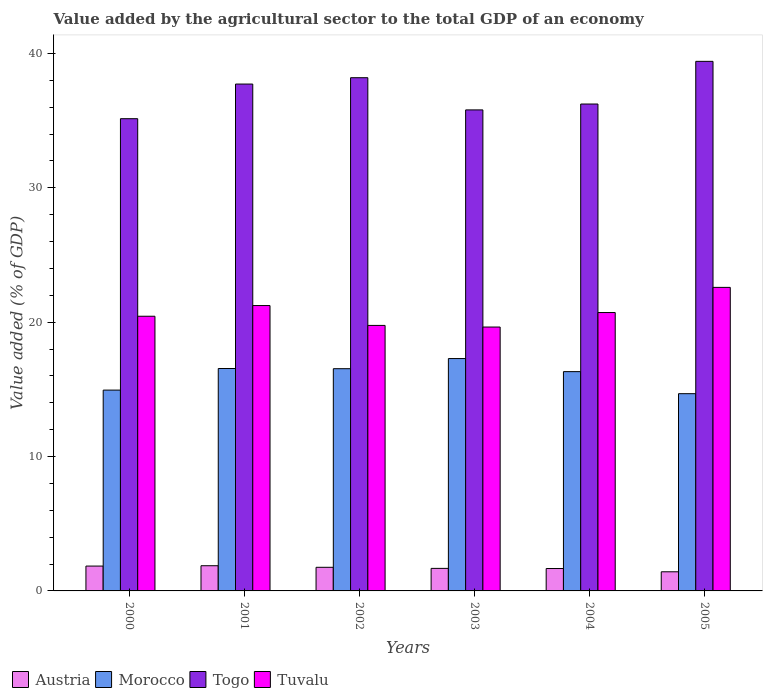How many bars are there on the 2nd tick from the left?
Offer a very short reply. 4. How many bars are there on the 5th tick from the right?
Give a very brief answer. 4. What is the label of the 1st group of bars from the left?
Provide a short and direct response. 2000. What is the value added by the agricultural sector to the total GDP in Togo in 2003?
Your response must be concise. 35.8. Across all years, what is the maximum value added by the agricultural sector to the total GDP in Morocco?
Your response must be concise. 17.29. Across all years, what is the minimum value added by the agricultural sector to the total GDP in Morocco?
Offer a very short reply. 14.68. In which year was the value added by the agricultural sector to the total GDP in Tuvalu maximum?
Keep it short and to the point. 2005. What is the total value added by the agricultural sector to the total GDP in Togo in the graph?
Your answer should be compact. 222.49. What is the difference between the value added by the agricultural sector to the total GDP in Austria in 2002 and that in 2005?
Your response must be concise. 0.33. What is the difference between the value added by the agricultural sector to the total GDP in Togo in 2000 and the value added by the agricultural sector to the total GDP in Austria in 2004?
Provide a succinct answer. 33.47. What is the average value added by the agricultural sector to the total GDP in Tuvalu per year?
Your answer should be compact. 20.73. In the year 2004, what is the difference between the value added by the agricultural sector to the total GDP in Tuvalu and value added by the agricultural sector to the total GDP in Morocco?
Give a very brief answer. 4.4. In how many years, is the value added by the agricultural sector to the total GDP in Morocco greater than 38 %?
Ensure brevity in your answer.  0. What is the ratio of the value added by the agricultural sector to the total GDP in Togo in 2001 to that in 2005?
Give a very brief answer. 0.96. Is the value added by the agricultural sector to the total GDP in Austria in 2002 less than that in 2004?
Ensure brevity in your answer.  No. What is the difference between the highest and the second highest value added by the agricultural sector to the total GDP in Morocco?
Your answer should be very brief. 0.74. What is the difference between the highest and the lowest value added by the agricultural sector to the total GDP in Togo?
Make the answer very short. 4.27. In how many years, is the value added by the agricultural sector to the total GDP in Togo greater than the average value added by the agricultural sector to the total GDP in Togo taken over all years?
Offer a terse response. 3. Is it the case that in every year, the sum of the value added by the agricultural sector to the total GDP in Togo and value added by the agricultural sector to the total GDP in Austria is greater than the sum of value added by the agricultural sector to the total GDP in Morocco and value added by the agricultural sector to the total GDP in Tuvalu?
Your response must be concise. Yes. What does the 4th bar from the left in 2004 represents?
Provide a short and direct response. Tuvalu. What does the 2nd bar from the right in 2000 represents?
Your answer should be very brief. Togo. How many bars are there?
Offer a very short reply. 24. Are all the bars in the graph horizontal?
Your response must be concise. No. How many years are there in the graph?
Ensure brevity in your answer.  6. What is the difference between two consecutive major ticks on the Y-axis?
Provide a succinct answer. 10. Does the graph contain any zero values?
Provide a short and direct response. No. What is the title of the graph?
Offer a terse response. Value added by the agricultural sector to the total GDP of an economy. Does "Turkmenistan" appear as one of the legend labels in the graph?
Give a very brief answer. No. What is the label or title of the X-axis?
Your answer should be very brief. Years. What is the label or title of the Y-axis?
Your answer should be compact. Value added (% of GDP). What is the Value added (% of GDP) in Austria in 2000?
Offer a terse response. 1.85. What is the Value added (% of GDP) in Morocco in 2000?
Give a very brief answer. 14.94. What is the Value added (% of GDP) of Togo in 2000?
Offer a terse response. 35.14. What is the Value added (% of GDP) of Tuvalu in 2000?
Your answer should be very brief. 20.44. What is the Value added (% of GDP) in Austria in 2001?
Your answer should be compact. 1.87. What is the Value added (% of GDP) in Morocco in 2001?
Give a very brief answer. 16.55. What is the Value added (% of GDP) of Togo in 2001?
Ensure brevity in your answer.  37.72. What is the Value added (% of GDP) of Tuvalu in 2001?
Offer a very short reply. 21.24. What is the Value added (% of GDP) in Austria in 2002?
Your answer should be compact. 1.76. What is the Value added (% of GDP) in Morocco in 2002?
Offer a very short reply. 16.54. What is the Value added (% of GDP) in Togo in 2002?
Ensure brevity in your answer.  38.19. What is the Value added (% of GDP) in Tuvalu in 2002?
Make the answer very short. 19.76. What is the Value added (% of GDP) in Austria in 2003?
Your answer should be compact. 1.68. What is the Value added (% of GDP) in Morocco in 2003?
Your answer should be compact. 17.29. What is the Value added (% of GDP) in Togo in 2003?
Ensure brevity in your answer.  35.8. What is the Value added (% of GDP) of Tuvalu in 2003?
Ensure brevity in your answer.  19.64. What is the Value added (% of GDP) of Austria in 2004?
Keep it short and to the point. 1.67. What is the Value added (% of GDP) in Morocco in 2004?
Provide a succinct answer. 16.32. What is the Value added (% of GDP) of Togo in 2004?
Provide a succinct answer. 36.23. What is the Value added (% of GDP) in Tuvalu in 2004?
Give a very brief answer. 20.72. What is the Value added (% of GDP) in Austria in 2005?
Ensure brevity in your answer.  1.42. What is the Value added (% of GDP) of Morocco in 2005?
Provide a short and direct response. 14.68. What is the Value added (% of GDP) in Togo in 2005?
Make the answer very short. 39.41. What is the Value added (% of GDP) of Tuvalu in 2005?
Your answer should be very brief. 22.59. Across all years, what is the maximum Value added (% of GDP) in Austria?
Offer a terse response. 1.87. Across all years, what is the maximum Value added (% of GDP) in Morocco?
Give a very brief answer. 17.29. Across all years, what is the maximum Value added (% of GDP) of Togo?
Offer a very short reply. 39.41. Across all years, what is the maximum Value added (% of GDP) in Tuvalu?
Offer a very short reply. 22.59. Across all years, what is the minimum Value added (% of GDP) in Austria?
Keep it short and to the point. 1.42. Across all years, what is the minimum Value added (% of GDP) of Morocco?
Provide a short and direct response. 14.68. Across all years, what is the minimum Value added (% of GDP) of Togo?
Keep it short and to the point. 35.14. Across all years, what is the minimum Value added (% of GDP) in Tuvalu?
Offer a terse response. 19.64. What is the total Value added (% of GDP) in Austria in the graph?
Provide a succinct answer. 10.25. What is the total Value added (% of GDP) in Morocco in the graph?
Ensure brevity in your answer.  96.32. What is the total Value added (% of GDP) of Togo in the graph?
Provide a succinct answer. 222.49. What is the total Value added (% of GDP) in Tuvalu in the graph?
Provide a succinct answer. 124.38. What is the difference between the Value added (% of GDP) in Austria in 2000 and that in 2001?
Provide a short and direct response. -0.03. What is the difference between the Value added (% of GDP) of Morocco in 2000 and that in 2001?
Your answer should be very brief. -1.61. What is the difference between the Value added (% of GDP) in Togo in 2000 and that in 2001?
Offer a terse response. -2.58. What is the difference between the Value added (% of GDP) of Tuvalu in 2000 and that in 2001?
Give a very brief answer. -0.8. What is the difference between the Value added (% of GDP) of Austria in 2000 and that in 2002?
Keep it short and to the point. 0.09. What is the difference between the Value added (% of GDP) of Morocco in 2000 and that in 2002?
Make the answer very short. -1.59. What is the difference between the Value added (% of GDP) in Togo in 2000 and that in 2002?
Provide a succinct answer. -3.05. What is the difference between the Value added (% of GDP) in Tuvalu in 2000 and that in 2002?
Your response must be concise. 0.68. What is the difference between the Value added (% of GDP) in Austria in 2000 and that in 2003?
Offer a terse response. 0.17. What is the difference between the Value added (% of GDP) of Morocco in 2000 and that in 2003?
Your answer should be very brief. -2.35. What is the difference between the Value added (% of GDP) of Togo in 2000 and that in 2003?
Keep it short and to the point. -0.65. What is the difference between the Value added (% of GDP) in Tuvalu in 2000 and that in 2003?
Your response must be concise. 0.8. What is the difference between the Value added (% of GDP) of Austria in 2000 and that in 2004?
Provide a short and direct response. 0.18. What is the difference between the Value added (% of GDP) of Morocco in 2000 and that in 2004?
Give a very brief answer. -1.37. What is the difference between the Value added (% of GDP) in Togo in 2000 and that in 2004?
Your answer should be very brief. -1.09. What is the difference between the Value added (% of GDP) in Tuvalu in 2000 and that in 2004?
Offer a very short reply. -0.28. What is the difference between the Value added (% of GDP) in Austria in 2000 and that in 2005?
Provide a short and direct response. 0.43. What is the difference between the Value added (% of GDP) of Morocco in 2000 and that in 2005?
Offer a terse response. 0.27. What is the difference between the Value added (% of GDP) in Togo in 2000 and that in 2005?
Your response must be concise. -4.27. What is the difference between the Value added (% of GDP) in Tuvalu in 2000 and that in 2005?
Give a very brief answer. -2.15. What is the difference between the Value added (% of GDP) in Austria in 2001 and that in 2002?
Provide a short and direct response. 0.12. What is the difference between the Value added (% of GDP) in Morocco in 2001 and that in 2002?
Make the answer very short. 0.01. What is the difference between the Value added (% of GDP) of Togo in 2001 and that in 2002?
Ensure brevity in your answer.  -0.47. What is the difference between the Value added (% of GDP) of Tuvalu in 2001 and that in 2002?
Your answer should be compact. 1.48. What is the difference between the Value added (% of GDP) in Austria in 2001 and that in 2003?
Offer a terse response. 0.2. What is the difference between the Value added (% of GDP) in Morocco in 2001 and that in 2003?
Offer a very short reply. -0.74. What is the difference between the Value added (% of GDP) of Togo in 2001 and that in 2003?
Give a very brief answer. 1.92. What is the difference between the Value added (% of GDP) of Tuvalu in 2001 and that in 2003?
Provide a succinct answer. 1.6. What is the difference between the Value added (% of GDP) of Austria in 2001 and that in 2004?
Ensure brevity in your answer.  0.21. What is the difference between the Value added (% of GDP) in Morocco in 2001 and that in 2004?
Provide a short and direct response. 0.23. What is the difference between the Value added (% of GDP) in Togo in 2001 and that in 2004?
Provide a succinct answer. 1.49. What is the difference between the Value added (% of GDP) in Tuvalu in 2001 and that in 2004?
Your answer should be compact. 0.52. What is the difference between the Value added (% of GDP) in Austria in 2001 and that in 2005?
Offer a very short reply. 0.45. What is the difference between the Value added (% of GDP) of Morocco in 2001 and that in 2005?
Offer a terse response. 1.87. What is the difference between the Value added (% of GDP) of Togo in 2001 and that in 2005?
Ensure brevity in your answer.  -1.69. What is the difference between the Value added (% of GDP) in Tuvalu in 2001 and that in 2005?
Make the answer very short. -1.35. What is the difference between the Value added (% of GDP) in Austria in 2002 and that in 2003?
Offer a terse response. 0.08. What is the difference between the Value added (% of GDP) in Morocco in 2002 and that in 2003?
Offer a terse response. -0.75. What is the difference between the Value added (% of GDP) of Togo in 2002 and that in 2003?
Your answer should be very brief. 2.4. What is the difference between the Value added (% of GDP) in Tuvalu in 2002 and that in 2003?
Provide a short and direct response. 0.12. What is the difference between the Value added (% of GDP) in Austria in 2002 and that in 2004?
Offer a terse response. 0.09. What is the difference between the Value added (% of GDP) of Morocco in 2002 and that in 2004?
Your answer should be compact. 0.22. What is the difference between the Value added (% of GDP) in Togo in 2002 and that in 2004?
Offer a terse response. 1.96. What is the difference between the Value added (% of GDP) of Tuvalu in 2002 and that in 2004?
Your response must be concise. -0.96. What is the difference between the Value added (% of GDP) of Austria in 2002 and that in 2005?
Give a very brief answer. 0.33. What is the difference between the Value added (% of GDP) in Morocco in 2002 and that in 2005?
Offer a terse response. 1.86. What is the difference between the Value added (% of GDP) of Togo in 2002 and that in 2005?
Your answer should be very brief. -1.22. What is the difference between the Value added (% of GDP) of Tuvalu in 2002 and that in 2005?
Provide a succinct answer. -2.83. What is the difference between the Value added (% of GDP) of Austria in 2003 and that in 2004?
Ensure brevity in your answer.  0.01. What is the difference between the Value added (% of GDP) in Morocco in 2003 and that in 2004?
Offer a terse response. 0.97. What is the difference between the Value added (% of GDP) of Togo in 2003 and that in 2004?
Give a very brief answer. -0.44. What is the difference between the Value added (% of GDP) in Tuvalu in 2003 and that in 2004?
Your response must be concise. -1.08. What is the difference between the Value added (% of GDP) of Austria in 2003 and that in 2005?
Give a very brief answer. 0.25. What is the difference between the Value added (% of GDP) of Morocco in 2003 and that in 2005?
Provide a short and direct response. 2.61. What is the difference between the Value added (% of GDP) of Togo in 2003 and that in 2005?
Your answer should be compact. -3.61. What is the difference between the Value added (% of GDP) of Tuvalu in 2003 and that in 2005?
Your answer should be compact. -2.95. What is the difference between the Value added (% of GDP) of Austria in 2004 and that in 2005?
Offer a terse response. 0.24. What is the difference between the Value added (% of GDP) of Morocco in 2004 and that in 2005?
Ensure brevity in your answer.  1.64. What is the difference between the Value added (% of GDP) in Togo in 2004 and that in 2005?
Give a very brief answer. -3.18. What is the difference between the Value added (% of GDP) of Tuvalu in 2004 and that in 2005?
Your answer should be very brief. -1.87. What is the difference between the Value added (% of GDP) of Austria in 2000 and the Value added (% of GDP) of Morocco in 2001?
Your answer should be compact. -14.7. What is the difference between the Value added (% of GDP) of Austria in 2000 and the Value added (% of GDP) of Togo in 2001?
Keep it short and to the point. -35.87. What is the difference between the Value added (% of GDP) in Austria in 2000 and the Value added (% of GDP) in Tuvalu in 2001?
Provide a short and direct response. -19.39. What is the difference between the Value added (% of GDP) in Morocco in 2000 and the Value added (% of GDP) in Togo in 2001?
Your answer should be very brief. -22.78. What is the difference between the Value added (% of GDP) in Morocco in 2000 and the Value added (% of GDP) in Tuvalu in 2001?
Your answer should be compact. -6.29. What is the difference between the Value added (% of GDP) of Togo in 2000 and the Value added (% of GDP) of Tuvalu in 2001?
Offer a very short reply. 13.9. What is the difference between the Value added (% of GDP) in Austria in 2000 and the Value added (% of GDP) in Morocco in 2002?
Provide a short and direct response. -14.69. What is the difference between the Value added (% of GDP) in Austria in 2000 and the Value added (% of GDP) in Togo in 2002?
Keep it short and to the point. -36.34. What is the difference between the Value added (% of GDP) in Austria in 2000 and the Value added (% of GDP) in Tuvalu in 2002?
Make the answer very short. -17.91. What is the difference between the Value added (% of GDP) of Morocco in 2000 and the Value added (% of GDP) of Togo in 2002?
Your answer should be compact. -23.25. What is the difference between the Value added (% of GDP) of Morocco in 2000 and the Value added (% of GDP) of Tuvalu in 2002?
Your answer should be very brief. -4.81. What is the difference between the Value added (% of GDP) in Togo in 2000 and the Value added (% of GDP) in Tuvalu in 2002?
Your response must be concise. 15.38. What is the difference between the Value added (% of GDP) in Austria in 2000 and the Value added (% of GDP) in Morocco in 2003?
Your answer should be compact. -15.44. What is the difference between the Value added (% of GDP) in Austria in 2000 and the Value added (% of GDP) in Togo in 2003?
Offer a terse response. -33.95. What is the difference between the Value added (% of GDP) in Austria in 2000 and the Value added (% of GDP) in Tuvalu in 2003?
Keep it short and to the point. -17.79. What is the difference between the Value added (% of GDP) in Morocco in 2000 and the Value added (% of GDP) in Togo in 2003?
Offer a terse response. -20.85. What is the difference between the Value added (% of GDP) of Morocco in 2000 and the Value added (% of GDP) of Tuvalu in 2003?
Ensure brevity in your answer.  -4.69. What is the difference between the Value added (% of GDP) in Togo in 2000 and the Value added (% of GDP) in Tuvalu in 2003?
Your answer should be very brief. 15.5. What is the difference between the Value added (% of GDP) in Austria in 2000 and the Value added (% of GDP) in Morocco in 2004?
Your response must be concise. -14.47. What is the difference between the Value added (% of GDP) of Austria in 2000 and the Value added (% of GDP) of Togo in 2004?
Make the answer very short. -34.38. What is the difference between the Value added (% of GDP) in Austria in 2000 and the Value added (% of GDP) in Tuvalu in 2004?
Offer a terse response. -18.87. What is the difference between the Value added (% of GDP) in Morocco in 2000 and the Value added (% of GDP) in Togo in 2004?
Provide a succinct answer. -21.29. What is the difference between the Value added (% of GDP) in Morocco in 2000 and the Value added (% of GDP) in Tuvalu in 2004?
Provide a succinct answer. -5.77. What is the difference between the Value added (% of GDP) in Togo in 2000 and the Value added (% of GDP) in Tuvalu in 2004?
Provide a succinct answer. 14.43. What is the difference between the Value added (% of GDP) of Austria in 2000 and the Value added (% of GDP) of Morocco in 2005?
Make the answer very short. -12.83. What is the difference between the Value added (% of GDP) in Austria in 2000 and the Value added (% of GDP) in Togo in 2005?
Keep it short and to the point. -37.56. What is the difference between the Value added (% of GDP) in Austria in 2000 and the Value added (% of GDP) in Tuvalu in 2005?
Offer a very short reply. -20.74. What is the difference between the Value added (% of GDP) of Morocco in 2000 and the Value added (% of GDP) of Togo in 2005?
Ensure brevity in your answer.  -24.46. What is the difference between the Value added (% of GDP) of Morocco in 2000 and the Value added (% of GDP) of Tuvalu in 2005?
Ensure brevity in your answer.  -7.64. What is the difference between the Value added (% of GDP) in Togo in 2000 and the Value added (% of GDP) in Tuvalu in 2005?
Make the answer very short. 12.55. What is the difference between the Value added (% of GDP) of Austria in 2001 and the Value added (% of GDP) of Morocco in 2002?
Offer a terse response. -14.66. What is the difference between the Value added (% of GDP) of Austria in 2001 and the Value added (% of GDP) of Togo in 2002?
Your answer should be compact. -36.32. What is the difference between the Value added (% of GDP) of Austria in 2001 and the Value added (% of GDP) of Tuvalu in 2002?
Your answer should be compact. -17.88. What is the difference between the Value added (% of GDP) in Morocco in 2001 and the Value added (% of GDP) in Togo in 2002?
Provide a short and direct response. -21.64. What is the difference between the Value added (% of GDP) of Morocco in 2001 and the Value added (% of GDP) of Tuvalu in 2002?
Ensure brevity in your answer.  -3.21. What is the difference between the Value added (% of GDP) in Togo in 2001 and the Value added (% of GDP) in Tuvalu in 2002?
Provide a short and direct response. 17.96. What is the difference between the Value added (% of GDP) of Austria in 2001 and the Value added (% of GDP) of Morocco in 2003?
Make the answer very short. -15.42. What is the difference between the Value added (% of GDP) of Austria in 2001 and the Value added (% of GDP) of Togo in 2003?
Your answer should be very brief. -33.92. What is the difference between the Value added (% of GDP) of Austria in 2001 and the Value added (% of GDP) of Tuvalu in 2003?
Your answer should be very brief. -17.76. What is the difference between the Value added (% of GDP) in Morocco in 2001 and the Value added (% of GDP) in Togo in 2003?
Your answer should be very brief. -19.25. What is the difference between the Value added (% of GDP) of Morocco in 2001 and the Value added (% of GDP) of Tuvalu in 2003?
Offer a very short reply. -3.09. What is the difference between the Value added (% of GDP) of Togo in 2001 and the Value added (% of GDP) of Tuvalu in 2003?
Provide a succinct answer. 18.08. What is the difference between the Value added (% of GDP) of Austria in 2001 and the Value added (% of GDP) of Morocco in 2004?
Give a very brief answer. -14.44. What is the difference between the Value added (% of GDP) in Austria in 2001 and the Value added (% of GDP) in Togo in 2004?
Provide a short and direct response. -34.36. What is the difference between the Value added (% of GDP) of Austria in 2001 and the Value added (% of GDP) of Tuvalu in 2004?
Keep it short and to the point. -18.84. What is the difference between the Value added (% of GDP) of Morocco in 2001 and the Value added (% of GDP) of Togo in 2004?
Make the answer very short. -19.68. What is the difference between the Value added (% of GDP) in Morocco in 2001 and the Value added (% of GDP) in Tuvalu in 2004?
Your answer should be compact. -4.17. What is the difference between the Value added (% of GDP) in Togo in 2001 and the Value added (% of GDP) in Tuvalu in 2004?
Keep it short and to the point. 17. What is the difference between the Value added (% of GDP) in Austria in 2001 and the Value added (% of GDP) in Morocco in 2005?
Provide a short and direct response. -12.8. What is the difference between the Value added (% of GDP) in Austria in 2001 and the Value added (% of GDP) in Togo in 2005?
Keep it short and to the point. -37.53. What is the difference between the Value added (% of GDP) in Austria in 2001 and the Value added (% of GDP) in Tuvalu in 2005?
Ensure brevity in your answer.  -20.71. What is the difference between the Value added (% of GDP) in Morocco in 2001 and the Value added (% of GDP) in Togo in 2005?
Keep it short and to the point. -22.86. What is the difference between the Value added (% of GDP) of Morocco in 2001 and the Value added (% of GDP) of Tuvalu in 2005?
Keep it short and to the point. -6.04. What is the difference between the Value added (% of GDP) of Togo in 2001 and the Value added (% of GDP) of Tuvalu in 2005?
Offer a very short reply. 15.13. What is the difference between the Value added (% of GDP) of Austria in 2002 and the Value added (% of GDP) of Morocco in 2003?
Your answer should be compact. -15.53. What is the difference between the Value added (% of GDP) of Austria in 2002 and the Value added (% of GDP) of Togo in 2003?
Keep it short and to the point. -34.04. What is the difference between the Value added (% of GDP) of Austria in 2002 and the Value added (% of GDP) of Tuvalu in 2003?
Provide a short and direct response. -17.88. What is the difference between the Value added (% of GDP) in Morocco in 2002 and the Value added (% of GDP) in Togo in 2003?
Your response must be concise. -19.26. What is the difference between the Value added (% of GDP) in Morocco in 2002 and the Value added (% of GDP) in Tuvalu in 2003?
Your answer should be very brief. -3.1. What is the difference between the Value added (% of GDP) of Togo in 2002 and the Value added (% of GDP) of Tuvalu in 2003?
Make the answer very short. 18.55. What is the difference between the Value added (% of GDP) of Austria in 2002 and the Value added (% of GDP) of Morocco in 2004?
Provide a short and direct response. -14.56. What is the difference between the Value added (% of GDP) in Austria in 2002 and the Value added (% of GDP) in Togo in 2004?
Keep it short and to the point. -34.48. What is the difference between the Value added (% of GDP) in Austria in 2002 and the Value added (% of GDP) in Tuvalu in 2004?
Make the answer very short. -18.96. What is the difference between the Value added (% of GDP) of Morocco in 2002 and the Value added (% of GDP) of Togo in 2004?
Make the answer very short. -19.7. What is the difference between the Value added (% of GDP) in Morocco in 2002 and the Value added (% of GDP) in Tuvalu in 2004?
Ensure brevity in your answer.  -4.18. What is the difference between the Value added (% of GDP) of Togo in 2002 and the Value added (% of GDP) of Tuvalu in 2004?
Make the answer very short. 17.48. What is the difference between the Value added (% of GDP) of Austria in 2002 and the Value added (% of GDP) of Morocco in 2005?
Provide a short and direct response. -12.92. What is the difference between the Value added (% of GDP) of Austria in 2002 and the Value added (% of GDP) of Togo in 2005?
Provide a succinct answer. -37.65. What is the difference between the Value added (% of GDP) in Austria in 2002 and the Value added (% of GDP) in Tuvalu in 2005?
Your response must be concise. -20.83. What is the difference between the Value added (% of GDP) in Morocco in 2002 and the Value added (% of GDP) in Togo in 2005?
Your answer should be compact. -22.87. What is the difference between the Value added (% of GDP) of Morocco in 2002 and the Value added (% of GDP) of Tuvalu in 2005?
Ensure brevity in your answer.  -6.05. What is the difference between the Value added (% of GDP) in Togo in 2002 and the Value added (% of GDP) in Tuvalu in 2005?
Give a very brief answer. 15.6. What is the difference between the Value added (% of GDP) of Austria in 2003 and the Value added (% of GDP) of Morocco in 2004?
Offer a terse response. -14.64. What is the difference between the Value added (% of GDP) in Austria in 2003 and the Value added (% of GDP) in Togo in 2004?
Provide a short and direct response. -34.56. What is the difference between the Value added (% of GDP) in Austria in 2003 and the Value added (% of GDP) in Tuvalu in 2004?
Make the answer very short. -19.04. What is the difference between the Value added (% of GDP) in Morocco in 2003 and the Value added (% of GDP) in Togo in 2004?
Offer a very short reply. -18.94. What is the difference between the Value added (% of GDP) of Morocco in 2003 and the Value added (% of GDP) of Tuvalu in 2004?
Give a very brief answer. -3.42. What is the difference between the Value added (% of GDP) in Togo in 2003 and the Value added (% of GDP) in Tuvalu in 2004?
Ensure brevity in your answer.  15.08. What is the difference between the Value added (% of GDP) of Austria in 2003 and the Value added (% of GDP) of Morocco in 2005?
Offer a terse response. -13. What is the difference between the Value added (% of GDP) in Austria in 2003 and the Value added (% of GDP) in Togo in 2005?
Provide a short and direct response. -37.73. What is the difference between the Value added (% of GDP) in Austria in 2003 and the Value added (% of GDP) in Tuvalu in 2005?
Provide a succinct answer. -20.91. What is the difference between the Value added (% of GDP) in Morocco in 2003 and the Value added (% of GDP) in Togo in 2005?
Provide a succinct answer. -22.12. What is the difference between the Value added (% of GDP) of Morocco in 2003 and the Value added (% of GDP) of Tuvalu in 2005?
Make the answer very short. -5.3. What is the difference between the Value added (% of GDP) of Togo in 2003 and the Value added (% of GDP) of Tuvalu in 2005?
Your answer should be compact. 13.21. What is the difference between the Value added (% of GDP) of Austria in 2004 and the Value added (% of GDP) of Morocco in 2005?
Make the answer very short. -13.01. What is the difference between the Value added (% of GDP) of Austria in 2004 and the Value added (% of GDP) of Togo in 2005?
Ensure brevity in your answer.  -37.74. What is the difference between the Value added (% of GDP) in Austria in 2004 and the Value added (% of GDP) in Tuvalu in 2005?
Provide a succinct answer. -20.92. What is the difference between the Value added (% of GDP) of Morocco in 2004 and the Value added (% of GDP) of Togo in 2005?
Offer a terse response. -23.09. What is the difference between the Value added (% of GDP) of Morocco in 2004 and the Value added (% of GDP) of Tuvalu in 2005?
Your answer should be very brief. -6.27. What is the difference between the Value added (% of GDP) in Togo in 2004 and the Value added (% of GDP) in Tuvalu in 2005?
Keep it short and to the point. 13.65. What is the average Value added (% of GDP) in Austria per year?
Your response must be concise. 1.71. What is the average Value added (% of GDP) in Morocco per year?
Keep it short and to the point. 16.05. What is the average Value added (% of GDP) of Togo per year?
Ensure brevity in your answer.  37.08. What is the average Value added (% of GDP) of Tuvalu per year?
Your answer should be very brief. 20.73. In the year 2000, what is the difference between the Value added (% of GDP) in Austria and Value added (% of GDP) in Morocco?
Ensure brevity in your answer.  -13.09. In the year 2000, what is the difference between the Value added (% of GDP) in Austria and Value added (% of GDP) in Togo?
Offer a very short reply. -33.29. In the year 2000, what is the difference between the Value added (% of GDP) of Austria and Value added (% of GDP) of Tuvalu?
Offer a terse response. -18.59. In the year 2000, what is the difference between the Value added (% of GDP) of Morocco and Value added (% of GDP) of Togo?
Ensure brevity in your answer.  -20.2. In the year 2000, what is the difference between the Value added (% of GDP) of Morocco and Value added (% of GDP) of Tuvalu?
Give a very brief answer. -5.5. In the year 2000, what is the difference between the Value added (% of GDP) in Togo and Value added (% of GDP) in Tuvalu?
Keep it short and to the point. 14.7. In the year 2001, what is the difference between the Value added (% of GDP) in Austria and Value added (% of GDP) in Morocco?
Offer a terse response. -14.68. In the year 2001, what is the difference between the Value added (% of GDP) in Austria and Value added (% of GDP) in Togo?
Your response must be concise. -35.84. In the year 2001, what is the difference between the Value added (% of GDP) in Austria and Value added (% of GDP) in Tuvalu?
Offer a terse response. -19.36. In the year 2001, what is the difference between the Value added (% of GDP) in Morocco and Value added (% of GDP) in Togo?
Your answer should be compact. -21.17. In the year 2001, what is the difference between the Value added (% of GDP) of Morocco and Value added (% of GDP) of Tuvalu?
Offer a terse response. -4.69. In the year 2001, what is the difference between the Value added (% of GDP) of Togo and Value added (% of GDP) of Tuvalu?
Your answer should be compact. 16.48. In the year 2002, what is the difference between the Value added (% of GDP) in Austria and Value added (% of GDP) in Morocco?
Give a very brief answer. -14.78. In the year 2002, what is the difference between the Value added (% of GDP) of Austria and Value added (% of GDP) of Togo?
Offer a terse response. -36.43. In the year 2002, what is the difference between the Value added (% of GDP) of Austria and Value added (% of GDP) of Tuvalu?
Offer a very short reply. -18. In the year 2002, what is the difference between the Value added (% of GDP) of Morocco and Value added (% of GDP) of Togo?
Provide a succinct answer. -21.65. In the year 2002, what is the difference between the Value added (% of GDP) of Morocco and Value added (% of GDP) of Tuvalu?
Keep it short and to the point. -3.22. In the year 2002, what is the difference between the Value added (% of GDP) of Togo and Value added (% of GDP) of Tuvalu?
Make the answer very short. 18.43. In the year 2003, what is the difference between the Value added (% of GDP) in Austria and Value added (% of GDP) in Morocco?
Keep it short and to the point. -15.61. In the year 2003, what is the difference between the Value added (% of GDP) of Austria and Value added (% of GDP) of Togo?
Keep it short and to the point. -34.12. In the year 2003, what is the difference between the Value added (% of GDP) in Austria and Value added (% of GDP) in Tuvalu?
Offer a very short reply. -17.96. In the year 2003, what is the difference between the Value added (% of GDP) of Morocco and Value added (% of GDP) of Togo?
Your answer should be compact. -18.5. In the year 2003, what is the difference between the Value added (% of GDP) in Morocco and Value added (% of GDP) in Tuvalu?
Keep it short and to the point. -2.35. In the year 2003, what is the difference between the Value added (% of GDP) of Togo and Value added (% of GDP) of Tuvalu?
Offer a very short reply. 16.16. In the year 2004, what is the difference between the Value added (% of GDP) of Austria and Value added (% of GDP) of Morocco?
Your response must be concise. -14.65. In the year 2004, what is the difference between the Value added (% of GDP) in Austria and Value added (% of GDP) in Togo?
Give a very brief answer. -34.57. In the year 2004, what is the difference between the Value added (% of GDP) in Austria and Value added (% of GDP) in Tuvalu?
Give a very brief answer. -19.05. In the year 2004, what is the difference between the Value added (% of GDP) in Morocco and Value added (% of GDP) in Togo?
Provide a succinct answer. -19.91. In the year 2004, what is the difference between the Value added (% of GDP) of Morocco and Value added (% of GDP) of Tuvalu?
Your response must be concise. -4.4. In the year 2004, what is the difference between the Value added (% of GDP) in Togo and Value added (% of GDP) in Tuvalu?
Ensure brevity in your answer.  15.52. In the year 2005, what is the difference between the Value added (% of GDP) of Austria and Value added (% of GDP) of Morocco?
Offer a terse response. -13.25. In the year 2005, what is the difference between the Value added (% of GDP) in Austria and Value added (% of GDP) in Togo?
Provide a short and direct response. -37.99. In the year 2005, what is the difference between the Value added (% of GDP) in Austria and Value added (% of GDP) in Tuvalu?
Your response must be concise. -21.16. In the year 2005, what is the difference between the Value added (% of GDP) of Morocco and Value added (% of GDP) of Togo?
Offer a very short reply. -24.73. In the year 2005, what is the difference between the Value added (% of GDP) of Morocco and Value added (% of GDP) of Tuvalu?
Ensure brevity in your answer.  -7.91. In the year 2005, what is the difference between the Value added (% of GDP) of Togo and Value added (% of GDP) of Tuvalu?
Offer a terse response. 16.82. What is the ratio of the Value added (% of GDP) in Austria in 2000 to that in 2001?
Offer a very short reply. 0.99. What is the ratio of the Value added (% of GDP) of Morocco in 2000 to that in 2001?
Provide a short and direct response. 0.9. What is the ratio of the Value added (% of GDP) in Togo in 2000 to that in 2001?
Provide a succinct answer. 0.93. What is the ratio of the Value added (% of GDP) of Tuvalu in 2000 to that in 2001?
Your answer should be very brief. 0.96. What is the ratio of the Value added (% of GDP) of Austria in 2000 to that in 2002?
Provide a short and direct response. 1.05. What is the ratio of the Value added (% of GDP) of Morocco in 2000 to that in 2002?
Your answer should be very brief. 0.9. What is the ratio of the Value added (% of GDP) of Togo in 2000 to that in 2002?
Your answer should be very brief. 0.92. What is the ratio of the Value added (% of GDP) of Tuvalu in 2000 to that in 2002?
Keep it short and to the point. 1.03. What is the ratio of the Value added (% of GDP) of Austria in 2000 to that in 2003?
Offer a very short reply. 1.1. What is the ratio of the Value added (% of GDP) in Morocco in 2000 to that in 2003?
Keep it short and to the point. 0.86. What is the ratio of the Value added (% of GDP) of Togo in 2000 to that in 2003?
Your response must be concise. 0.98. What is the ratio of the Value added (% of GDP) of Tuvalu in 2000 to that in 2003?
Ensure brevity in your answer.  1.04. What is the ratio of the Value added (% of GDP) of Austria in 2000 to that in 2004?
Make the answer very short. 1.11. What is the ratio of the Value added (% of GDP) in Morocco in 2000 to that in 2004?
Keep it short and to the point. 0.92. What is the ratio of the Value added (% of GDP) in Togo in 2000 to that in 2004?
Offer a very short reply. 0.97. What is the ratio of the Value added (% of GDP) of Tuvalu in 2000 to that in 2004?
Give a very brief answer. 0.99. What is the ratio of the Value added (% of GDP) in Austria in 2000 to that in 2005?
Provide a succinct answer. 1.3. What is the ratio of the Value added (% of GDP) in Morocco in 2000 to that in 2005?
Offer a terse response. 1.02. What is the ratio of the Value added (% of GDP) in Togo in 2000 to that in 2005?
Offer a very short reply. 0.89. What is the ratio of the Value added (% of GDP) in Tuvalu in 2000 to that in 2005?
Make the answer very short. 0.91. What is the ratio of the Value added (% of GDP) in Austria in 2001 to that in 2002?
Your answer should be compact. 1.07. What is the ratio of the Value added (% of GDP) in Morocco in 2001 to that in 2002?
Your response must be concise. 1. What is the ratio of the Value added (% of GDP) in Togo in 2001 to that in 2002?
Provide a succinct answer. 0.99. What is the ratio of the Value added (% of GDP) in Tuvalu in 2001 to that in 2002?
Your answer should be very brief. 1.07. What is the ratio of the Value added (% of GDP) of Austria in 2001 to that in 2003?
Give a very brief answer. 1.12. What is the ratio of the Value added (% of GDP) of Morocco in 2001 to that in 2003?
Keep it short and to the point. 0.96. What is the ratio of the Value added (% of GDP) of Togo in 2001 to that in 2003?
Your answer should be very brief. 1.05. What is the ratio of the Value added (% of GDP) in Tuvalu in 2001 to that in 2003?
Your response must be concise. 1.08. What is the ratio of the Value added (% of GDP) of Austria in 2001 to that in 2004?
Your answer should be compact. 1.13. What is the ratio of the Value added (% of GDP) in Morocco in 2001 to that in 2004?
Your answer should be compact. 1.01. What is the ratio of the Value added (% of GDP) of Togo in 2001 to that in 2004?
Ensure brevity in your answer.  1.04. What is the ratio of the Value added (% of GDP) of Tuvalu in 2001 to that in 2004?
Offer a terse response. 1.03. What is the ratio of the Value added (% of GDP) of Austria in 2001 to that in 2005?
Make the answer very short. 1.32. What is the ratio of the Value added (% of GDP) of Morocco in 2001 to that in 2005?
Offer a very short reply. 1.13. What is the ratio of the Value added (% of GDP) in Togo in 2001 to that in 2005?
Keep it short and to the point. 0.96. What is the ratio of the Value added (% of GDP) of Tuvalu in 2001 to that in 2005?
Offer a very short reply. 0.94. What is the ratio of the Value added (% of GDP) of Austria in 2002 to that in 2003?
Keep it short and to the point. 1.05. What is the ratio of the Value added (% of GDP) in Morocco in 2002 to that in 2003?
Your answer should be very brief. 0.96. What is the ratio of the Value added (% of GDP) in Togo in 2002 to that in 2003?
Offer a very short reply. 1.07. What is the ratio of the Value added (% of GDP) of Tuvalu in 2002 to that in 2003?
Ensure brevity in your answer.  1.01. What is the ratio of the Value added (% of GDP) of Austria in 2002 to that in 2004?
Offer a terse response. 1.05. What is the ratio of the Value added (% of GDP) of Morocco in 2002 to that in 2004?
Provide a short and direct response. 1.01. What is the ratio of the Value added (% of GDP) in Togo in 2002 to that in 2004?
Ensure brevity in your answer.  1.05. What is the ratio of the Value added (% of GDP) of Tuvalu in 2002 to that in 2004?
Make the answer very short. 0.95. What is the ratio of the Value added (% of GDP) in Austria in 2002 to that in 2005?
Provide a succinct answer. 1.23. What is the ratio of the Value added (% of GDP) in Morocco in 2002 to that in 2005?
Offer a very short reply. 1.13. What is the ratio of the Value added (% of GDP) in Togo in 2002 to that in 2005?
Your answer should be compact. 0.97. What is the ratio of the Value added (% of GDP) of Tuvalu in 2002 to that in 2005?
Ensure brevity in your answer.  0.87. What is the ratio of the Value added (% of GDP) in Austria in 2003 to that in 2004?
Your answer should be very brief. 1.01. What is the ratio of the Value added (% of GDP) in Morocco in 2003 to that in 2004?
Provide a succinct answer. 1.06. What is the ratio of the Value added (% of GDP) of Togo in 2003 to that in 2004?
Give a very brief answer. 0.99. What is the ratio of the Value added (% of GDP) in Tuvalu in 2003 to that in 2004?
Your answer should be compact. 0.95. What is the ratio of the Value added (% of GDP) in Austria in 2003 to that in 2005?
Offer a very short reply. 1.18. What is the ratio of the Value added (% of GDP) of Morocco in 2003 to that in 2005?
Your response must be concise. 1.18. What is the ratio of the Value added (% of GDP) in Togo in 2003 to that in 2005?
Provide a short and direct response. 0.91. What is the ratio of the Value added (% of GDP) in Tuvalu in 2003 to that in 2005?
Provide a short and direct response. 0.87. What is the ratio of the Value added (% of GDP) in Austria in 2004 to that in 2005?
Your answer should be compact. 1.17. What is the ratio of the Value added (% of GDP) of Morocco in 2004 to that in 2005?
Ensure brevity in your answer.  1.11. What is the ratio of the Value added (% of GDP) of Togo in 2004 to that in 2005?
Make the answer very short. 0.92. What is the ratio of the Value added (% of GDP) in Tuvalu in 2004 to that in 2005?
Offer a very short reply. 0.92. What is the difference between the highest and the second highest Value added (% of GDP) of Austria?
Your answer should be compact. 0.03. What is the difference between the highest and the second highest Value added (% of GDP) in Morocco?
Make the answer very short. 0.74. What is the difference between the highest and the second highest Value added (% of GDP) in Togo?
Offer a very short reply. 1.22. What is the difference between the highest and the second highest Value added (% of GDP) in Tuvalu?
Offer a terse response. 1.35. What is the difference between the highest and the lowest Value added (% of GDP) in Austria?
Your answer should be compact. 0.45. What is the difference between the highest and the lowest Value added (% of GDP) of Morocco?
Ensure brevity in your answer.  2.61. What is the difference between the highest and the lowest Value added (% of GDP) in Togo?
Make the answer very short. 4.27. What is the difference between the highest and the lowest Value added (% of GDP) of Tuvalu?
Your answer should be very brief. 2.95. 